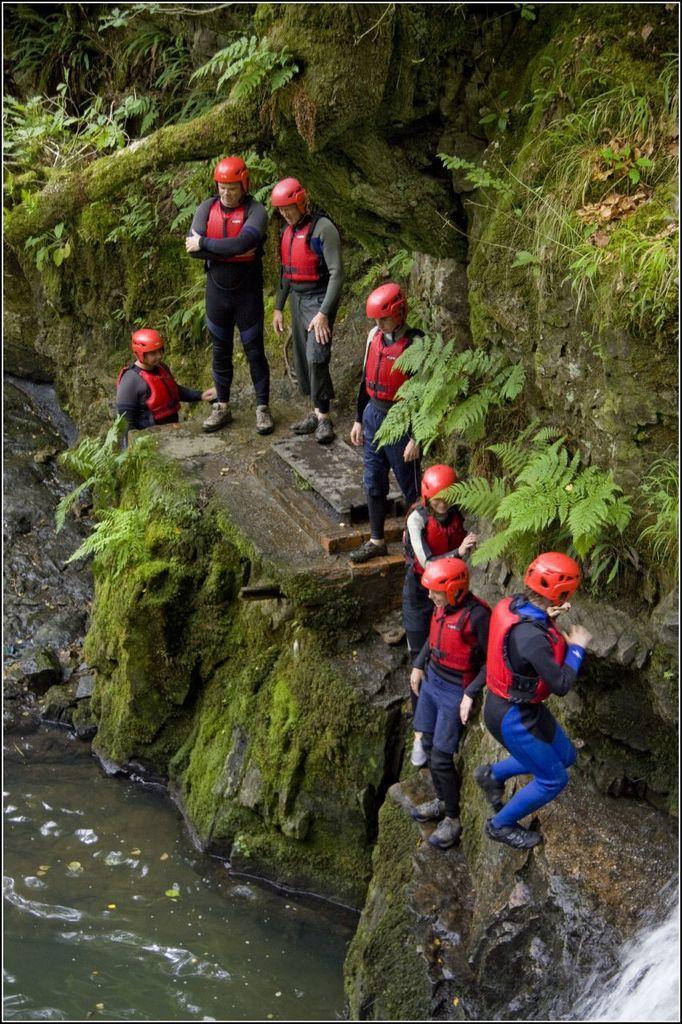Describe this image in one or two sentences. In this image I can see the group of people standing on the rock. These people are wearing the red color aprons and also red color helmets. To the side of the people I can see the water. In the background there are many trees. 